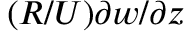Convert formula to latex. <formula><loc_0><loc_0><loc_500><loc_500>( R / U ) \partial w / \partial z</formula> 